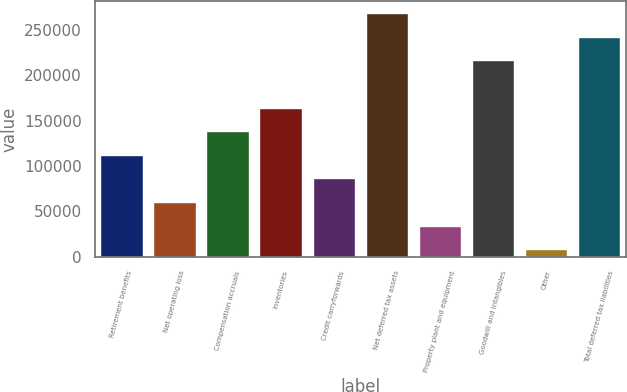Convert chart to OTSL. <chart><loc_0><loc_0><loc_500><loc_500><bar_chart><fcel>Retirement benefits<fcel>Net operating loss<fcel>Compensation accruals<fcel>Inventories<fcel>Credit carryforwards<fcel>Net deferred tax assets<fcel>Property plant and equipment<fcel>Goodwill and intangibles<fcel>Other<fcel>Total deferred tax liabilities<nl><fcel>112345<fcel>60321.8<fcel>138356<fcel>164367<fcel>86333.2<fcel>268413<fcel>34310.4<fcel>216390<fcel>8299<fcel>242402<nl></chart> 